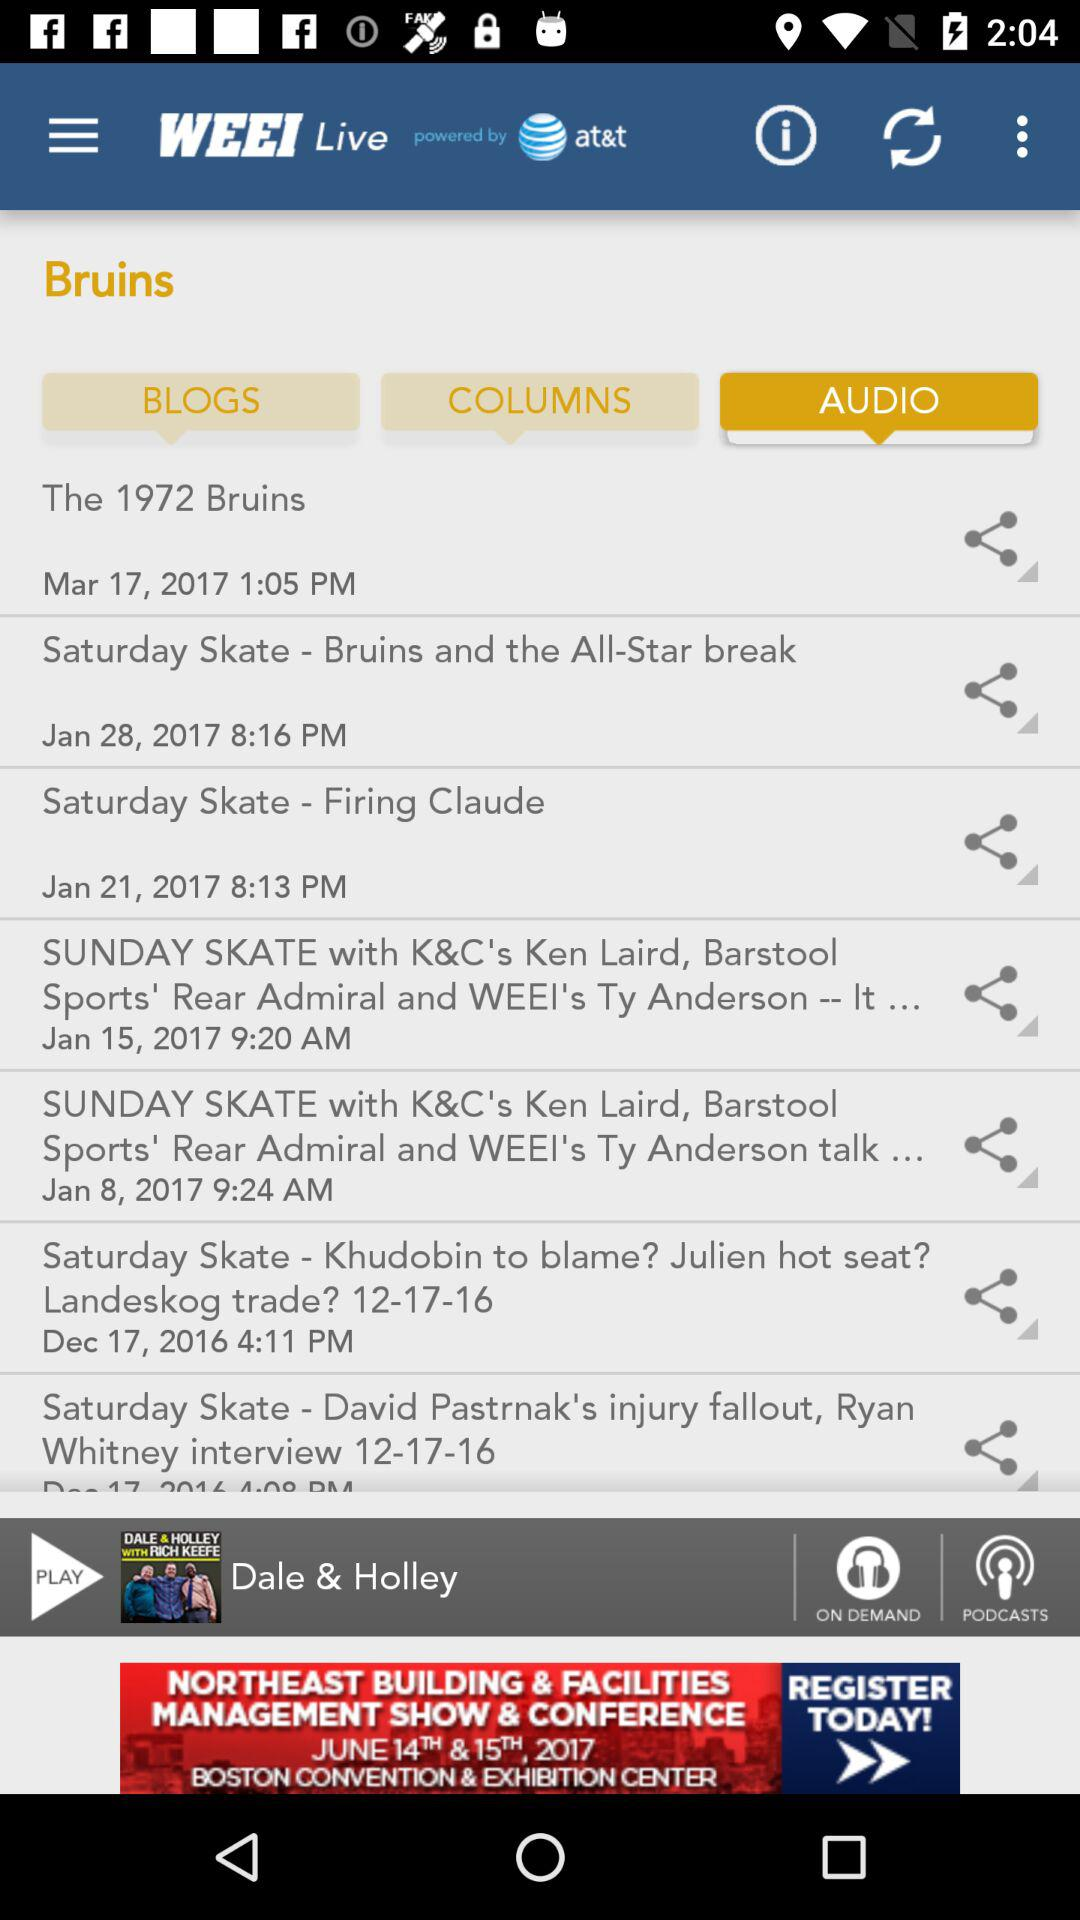What is the date and time of the audio "The 1972 Bruins"? The date and time of the audio are March 17, 2017 and 1:05 PM. 